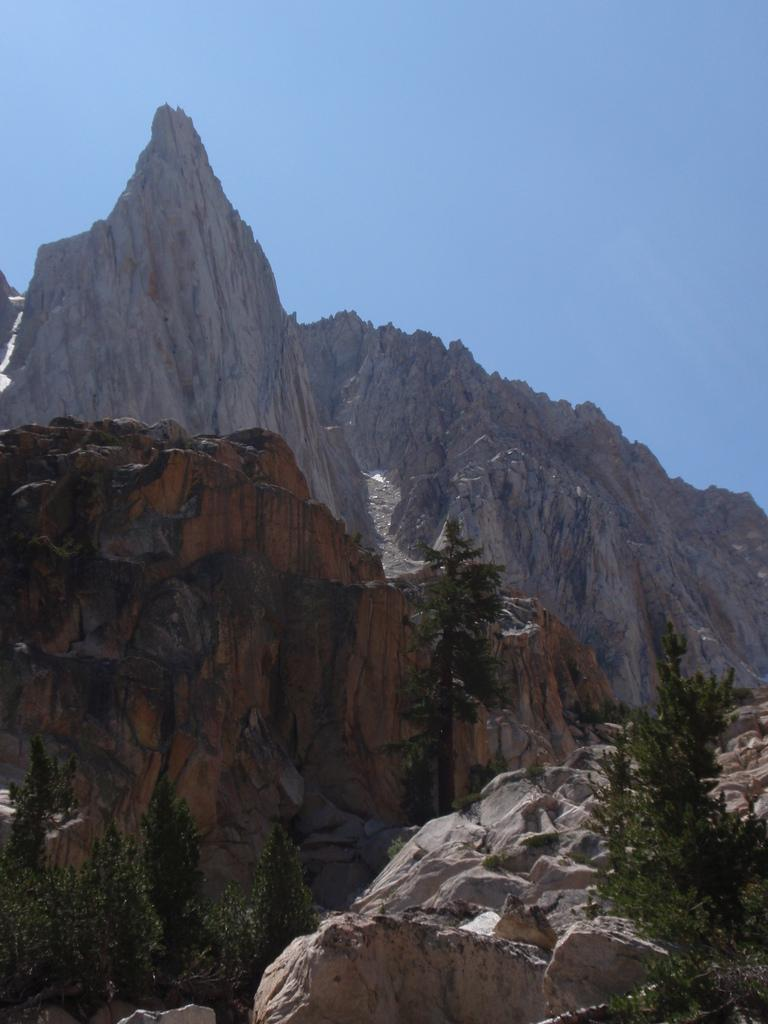What type of vegetation is present in the image? There are trees in the image. What other natural elements can be seen in the image? There are rocks visible in the image. What is visible in the background of the image? There is a mountain and the sky visible in the background of the image. What type of club can be seen in the image? There is no club present in the image; it features trees, rocks, a mountain, and the sky. How does the wind affect the trees in the image? The image does not provide any information about the wind or its effect on the trees. 